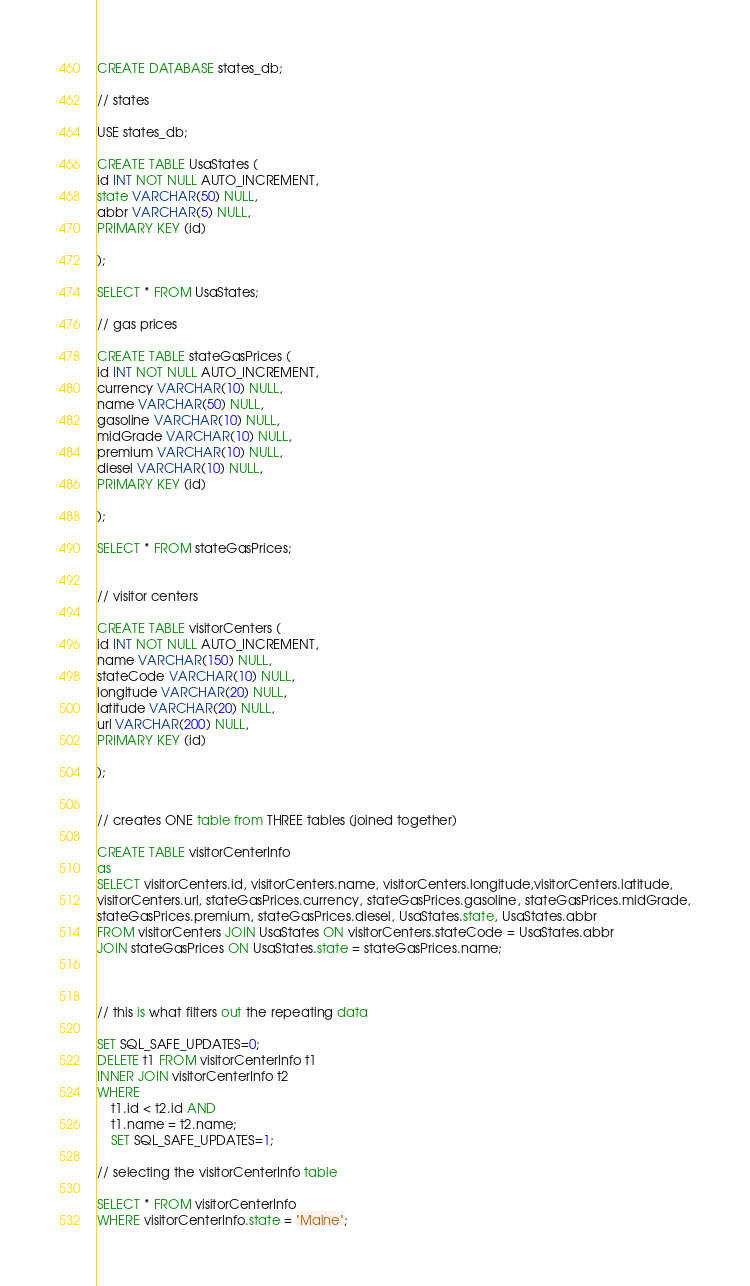<code> <loc_0><loc_0><loc_500><loc_500><_SQL_>CREATE DATABASE states_db;

// states 

USE states_db;

CREATE TABLE UsaStates (
id INT NOT NULL AUTO_INCREMENT,
state VARCHAR(50) NULL,
abbr VARCHAR(5) NULL,
PRIMARY KEY (id)

);

SELECT * FROM UsaStates;

// gas prices 

CREATE TABLE stateGasPrices (
id INT NOT NULL AUTO_INCREMENT,
currency VARCHAR(10) NULL,
name VARCHAR(50) NULL,
gasoline VARCHAR(10) NULL,
midGrade VARCHAR(10) NULL,
premium VARCHAR(10) NULL,
diesel VARCHAR(10) NULL,
PRIMARY KEY (id)

);

SELECT * FROM stateGasPrices;


// visitor centers

CREATE TABLE visitorCenters (
id INT NOT NULL AUTO_INCREMENT,
name VARCHAR(150) NULL,
stateCode VARCHAR(10) NULL,
longitude VARCHAR(20) NULL,
latitude VARCHAR(20) NULL,
url VARCHAR(200) NULL,
PRIMARY KEY (id)

);


// creates ONE table from THREE tables (joined together)

CREATE TABLE visitorCenterInfo
as
SELECT visitorCenters.id, visitorCenters.name, visitorCenters.longitude,visitorCenters.latitude,
visitorCenters.url, stateGasPrices.currency, stateGasPrices.gasoline, stateGasPrices.midGrade,
stateGasPrices.premium, stateGasPrices.diesel, UsaStates.state, UsaStates.abbr
FROM visitorCenters JOIN UsaStates ON visitorCenters.stateCode = UsaStates.abbr
JOIN stateGasPrices ON UsaStates.state = stateGasPrices.name;



// this is what filters out the repeating data

SET SQL_SAFE_UPDATES=0;
DELETE t1 FROM visitorCenterInfo t1
INNER JOIN visitorCenterInfo t2 
WHERE 
    t1.id < t2.id AND 
    t1.name = t2.name;
    SET SQL_SAFE_UPDATES=1;

// selecting the visitorCenterInfo table 

SELECT * FROM visitorCenterInfo
WHERE visitorCenterInfo.state = "Maine";
</code> 